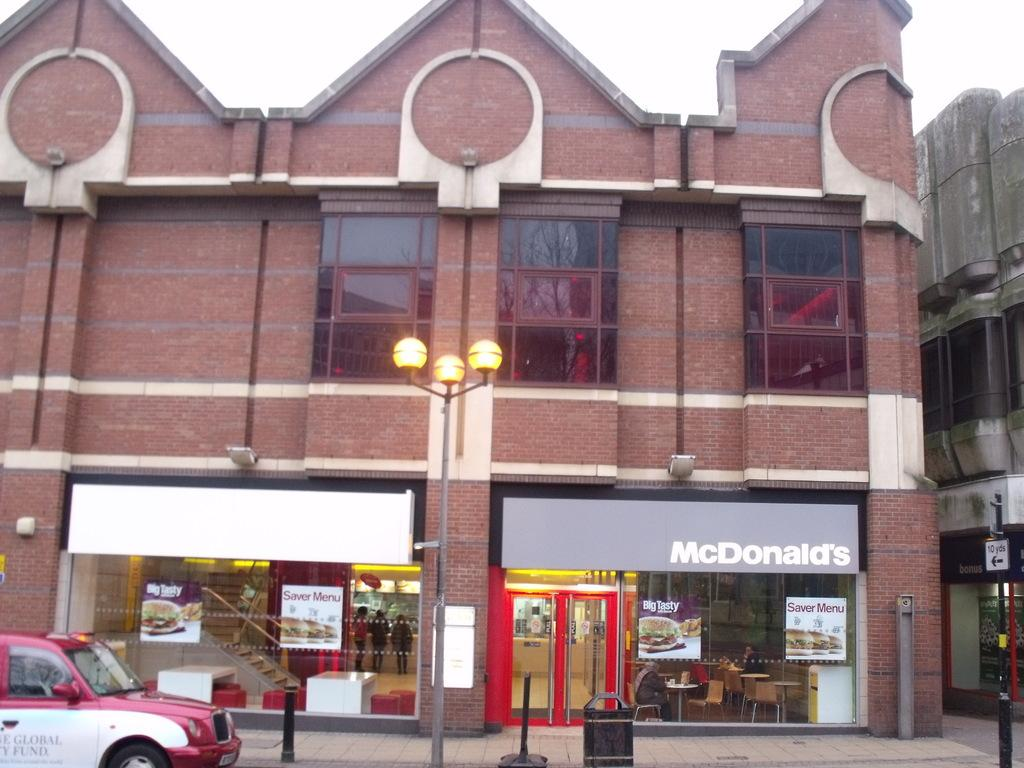Provide a one-sentence caption for the provided image. A garbage can sits out in front of the mcdonalds. 